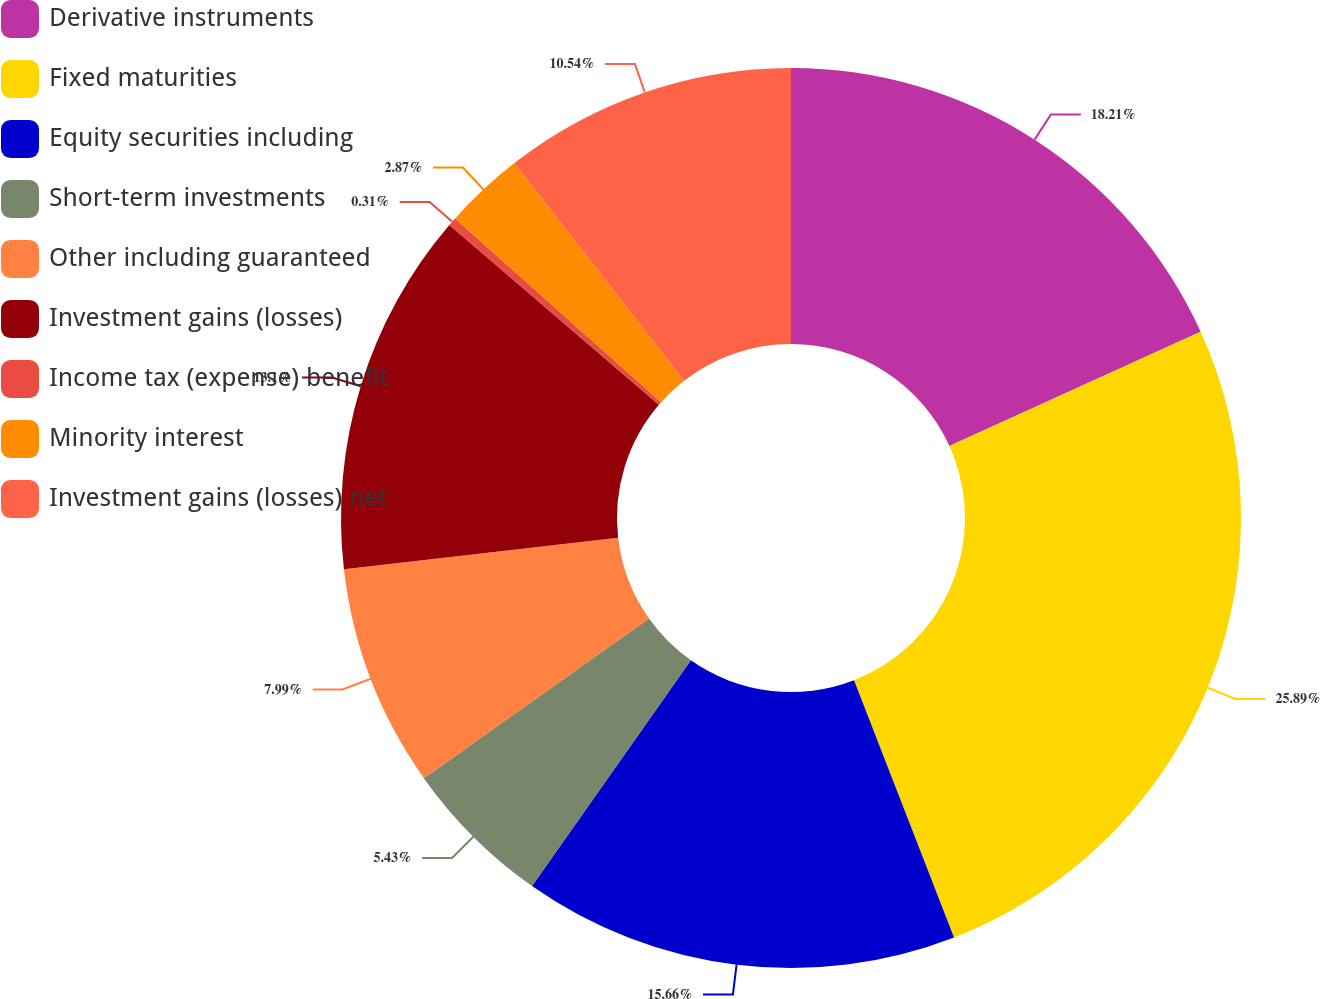<chart> <loc_0><loc_0><loc_500><loc_500><pie_chart><fcel>Derivative instruments<fcel>Fixed maturities<fcel>Equity securities including<fcel>Short-term investments<fcel>Other including guaranteed<fcel>Investment gains (losses)<fcel>Income tax (expense) benefit<fcel>Minority interest<fcel>Investment gains (losses) net<nl><fcel>18.21%<fcel>25.89%<fcel>15.66%<fcel>5.43%<fcel>7.99%<fcel>13.1%<fcel>0.31%<fcel>2.87%<fcel>10.54%<nl></chart> 